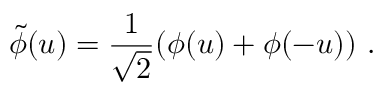<formula> <loc_0><loc_0><loc_500><loc_500>\tilde { \phi } ( u ) = \frac { 1 } { \sqrt { 2 } } ( \phi ( u ) + \phi ( - u ) ) \ .</formula> 